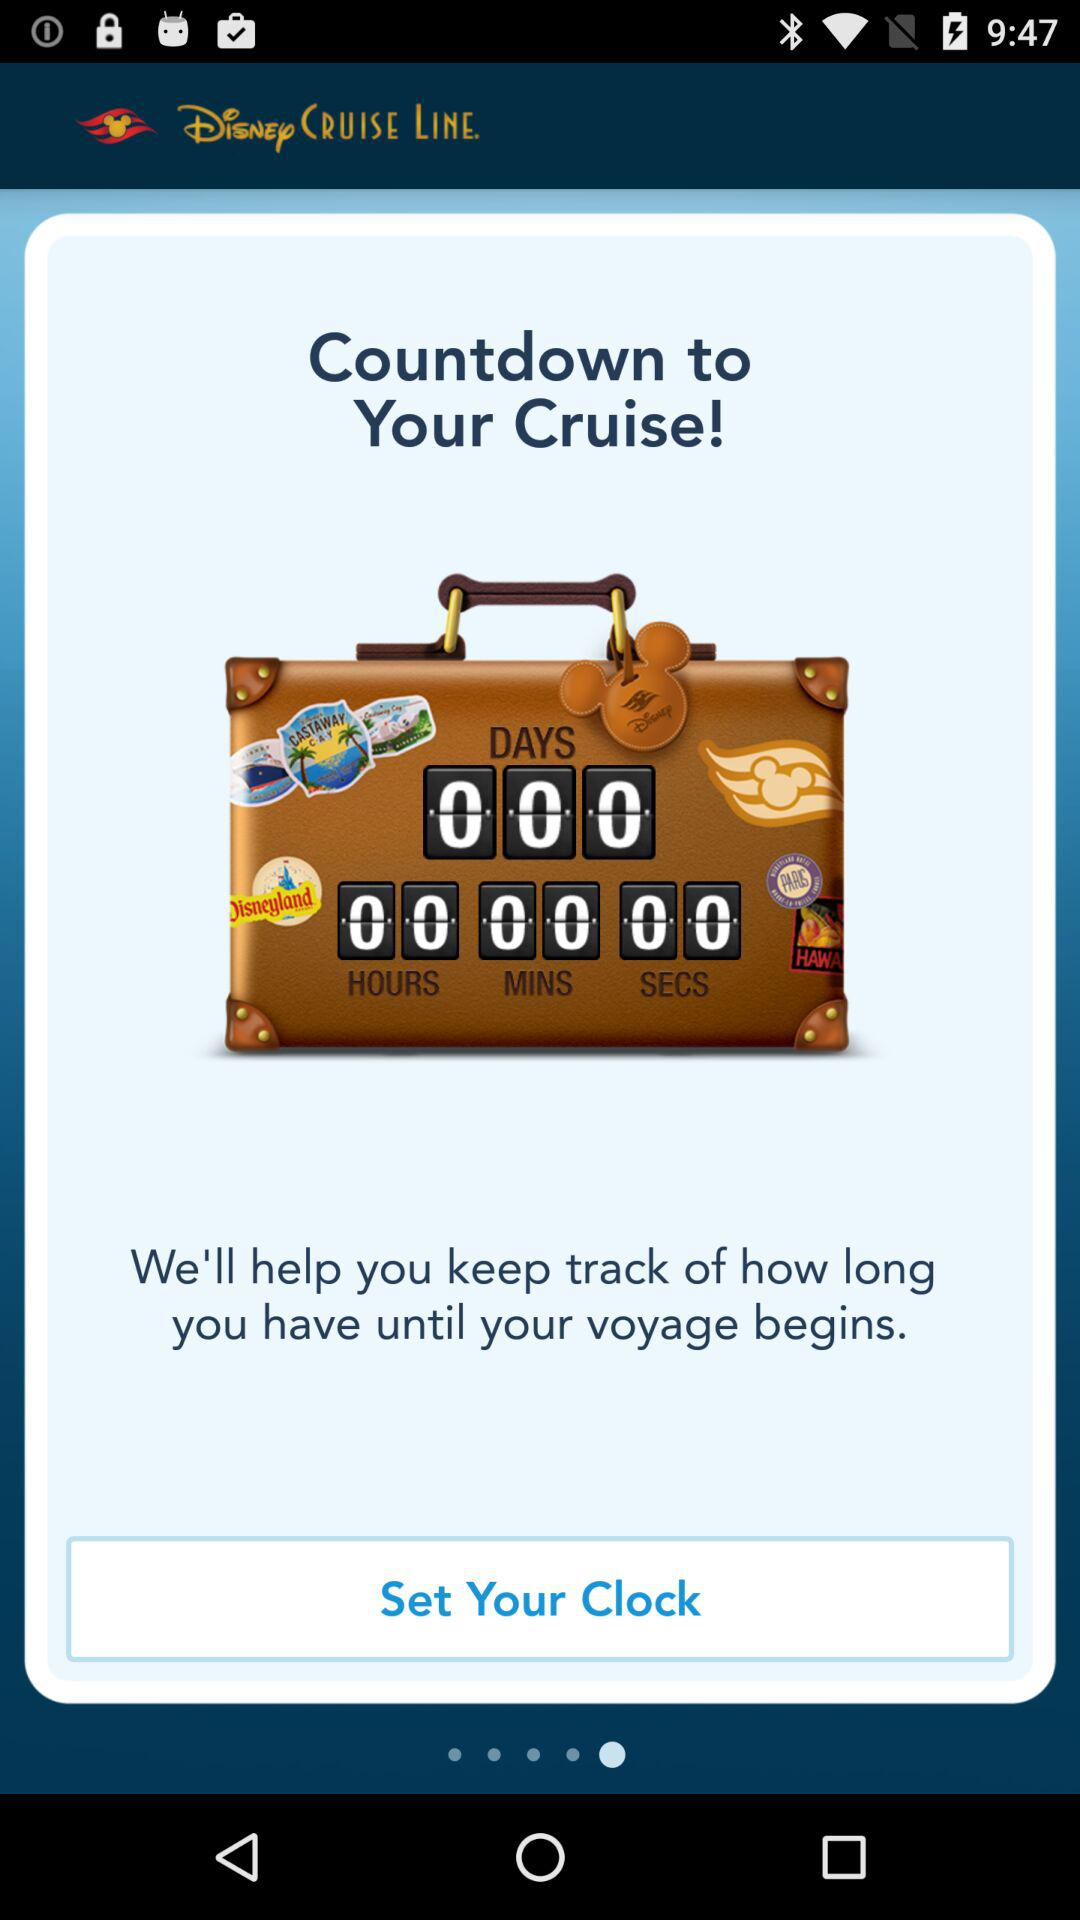How many minutes and hours are displayed on the screen? There are 0 minutes and 0 hours displayed on the screen. 